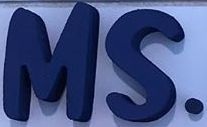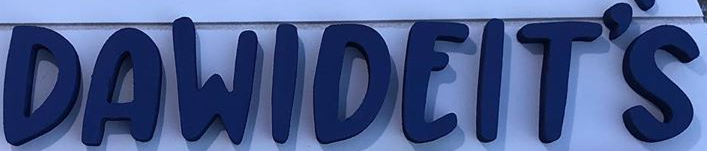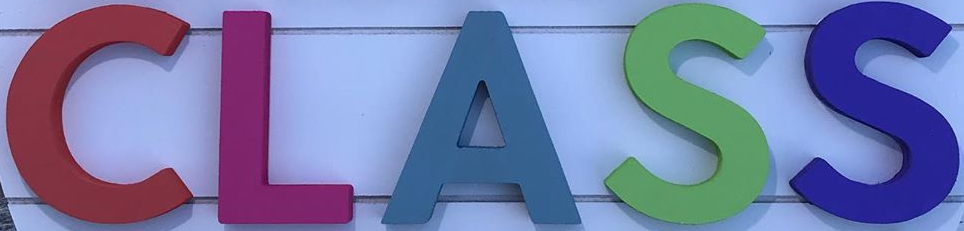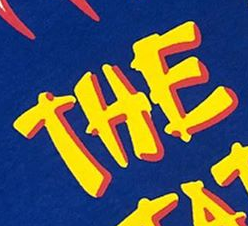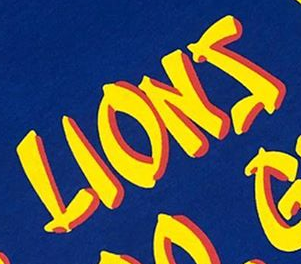Identify the words shown in these images in order, separated by a semicolon. MS.; DAWIDEIT'S; CLASS; THE; LIONS 